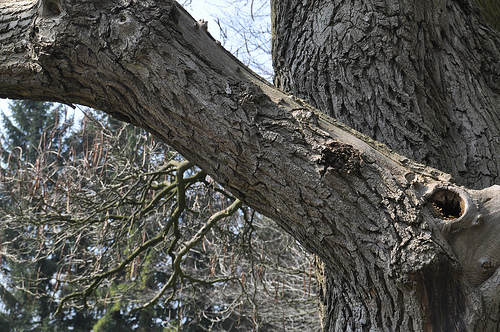<image>
Is the branch on the tree? No. The branch is not positioned on the tree. They may be near each other, but the branch is not supported by or resting on top of the tree. 